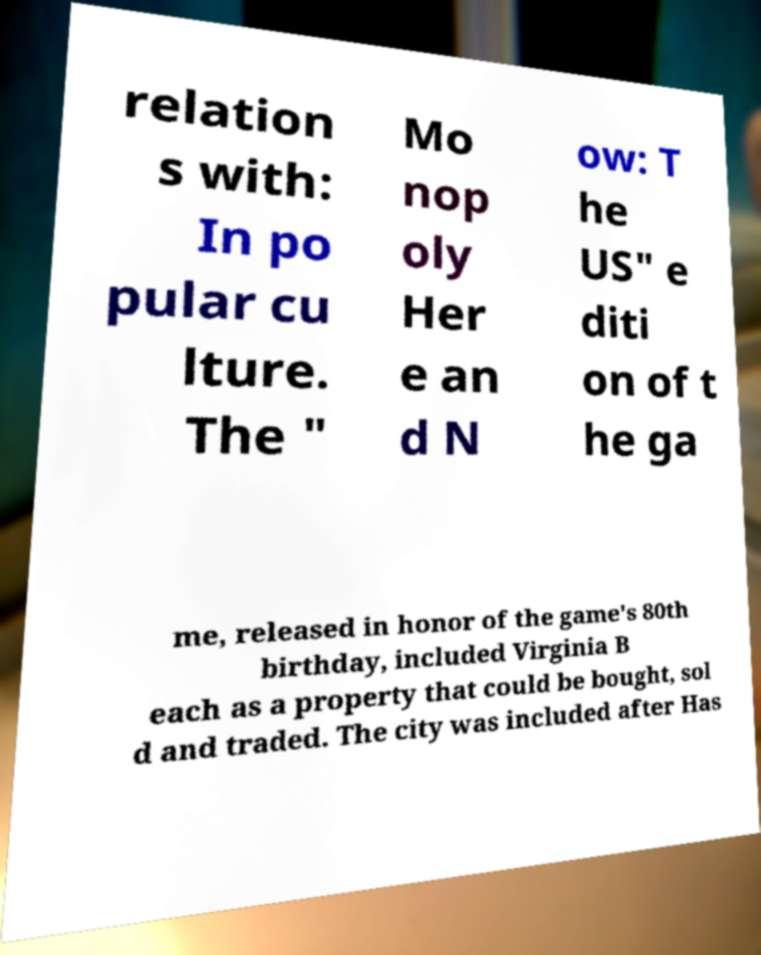Could you assist in decoding the text presented in this image and type it out clearly? relation s with: In po pular cu lture. The " Mo nop oly Her e an d N ow: T he US" e diti on of t he ga me, released in honor of the game's 80th birthday, included Virginia B each as a property that could be bought, sol d and traded. The city was included after Has 